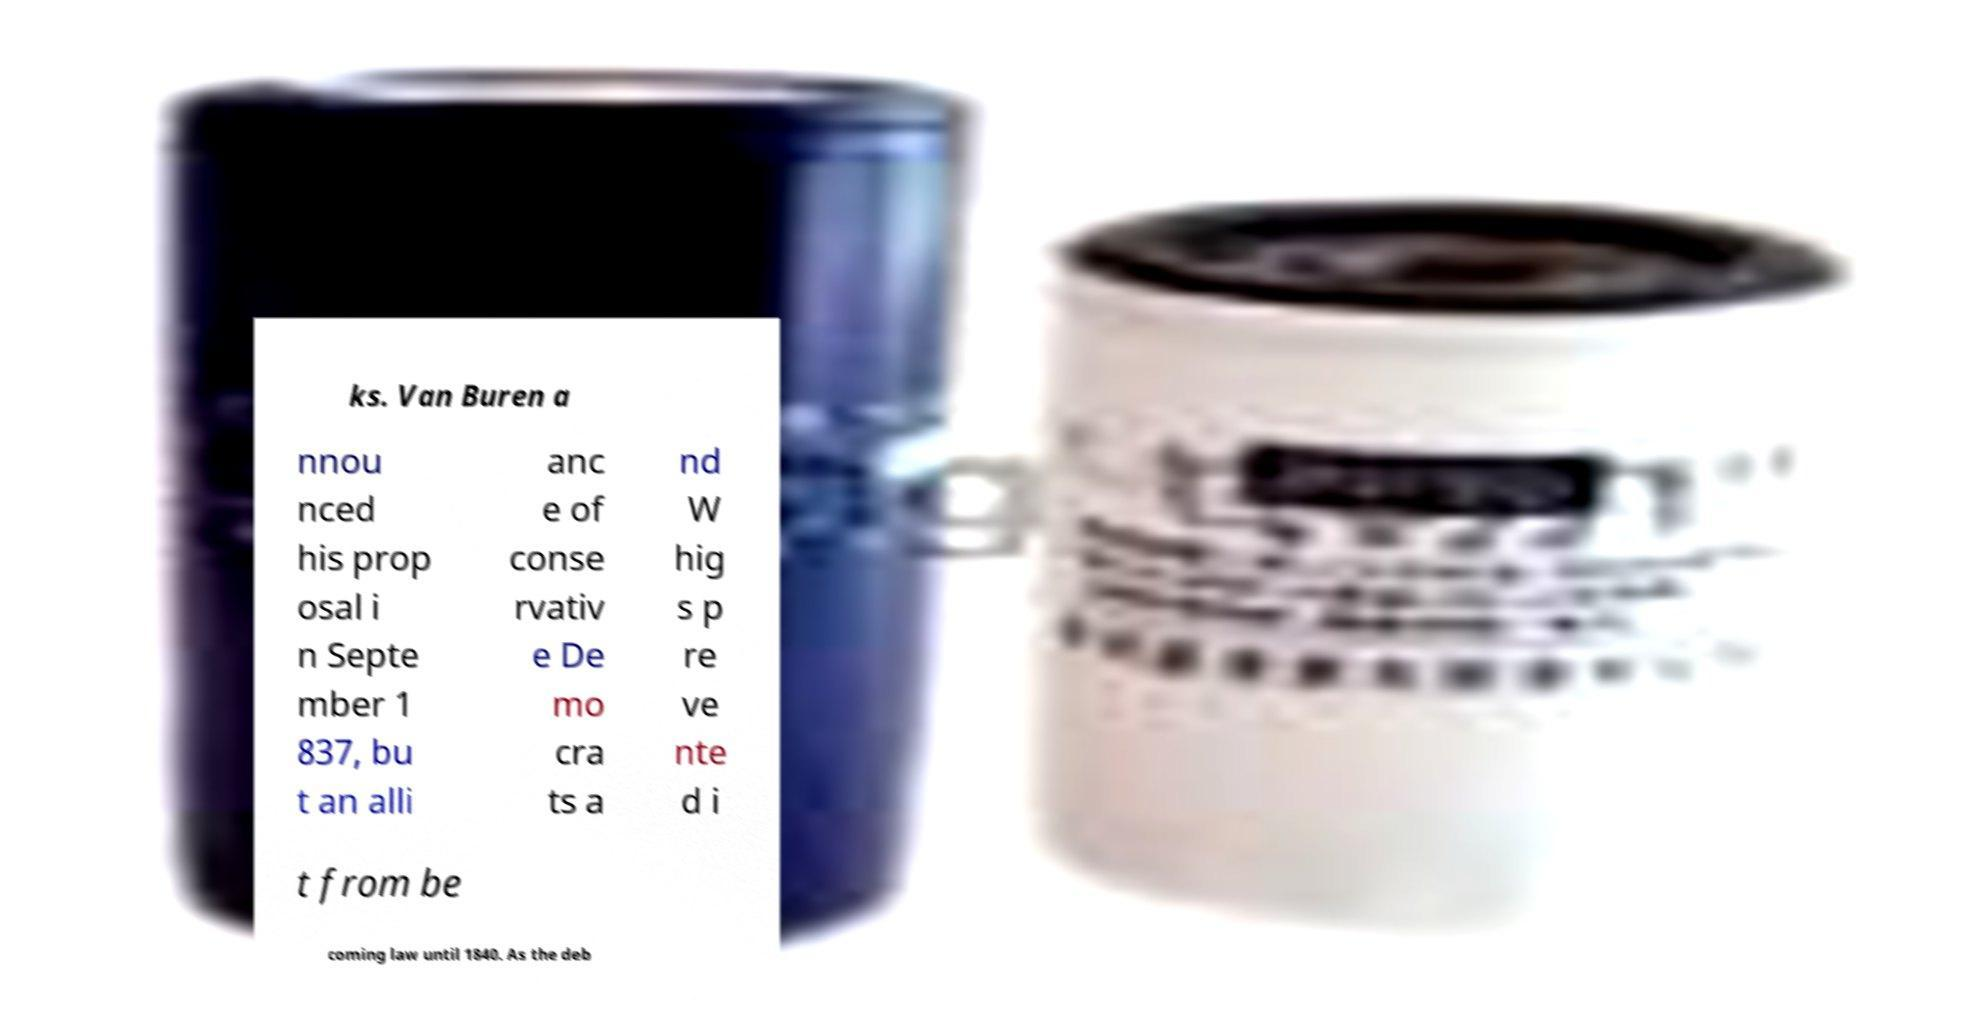I need the written content from this picture converted into text. Can you do that? ks. Van Buren a nnou nced his prop osal i n Septe mber 1 837, bu t an alli anc e of conse rvativ e De mo cra ts a nd W hig s p re ve nte d i t from be coming law until 1840. As the deb 